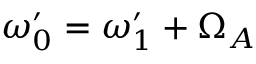Convert formula to latex. <formula><loc_0><loc_0><loc_500><loc_500>\omega _ { 0 } ^ { \prime } = \omega _ { 1 } ^ { \prime } + \Omega _ { A }</formula> 